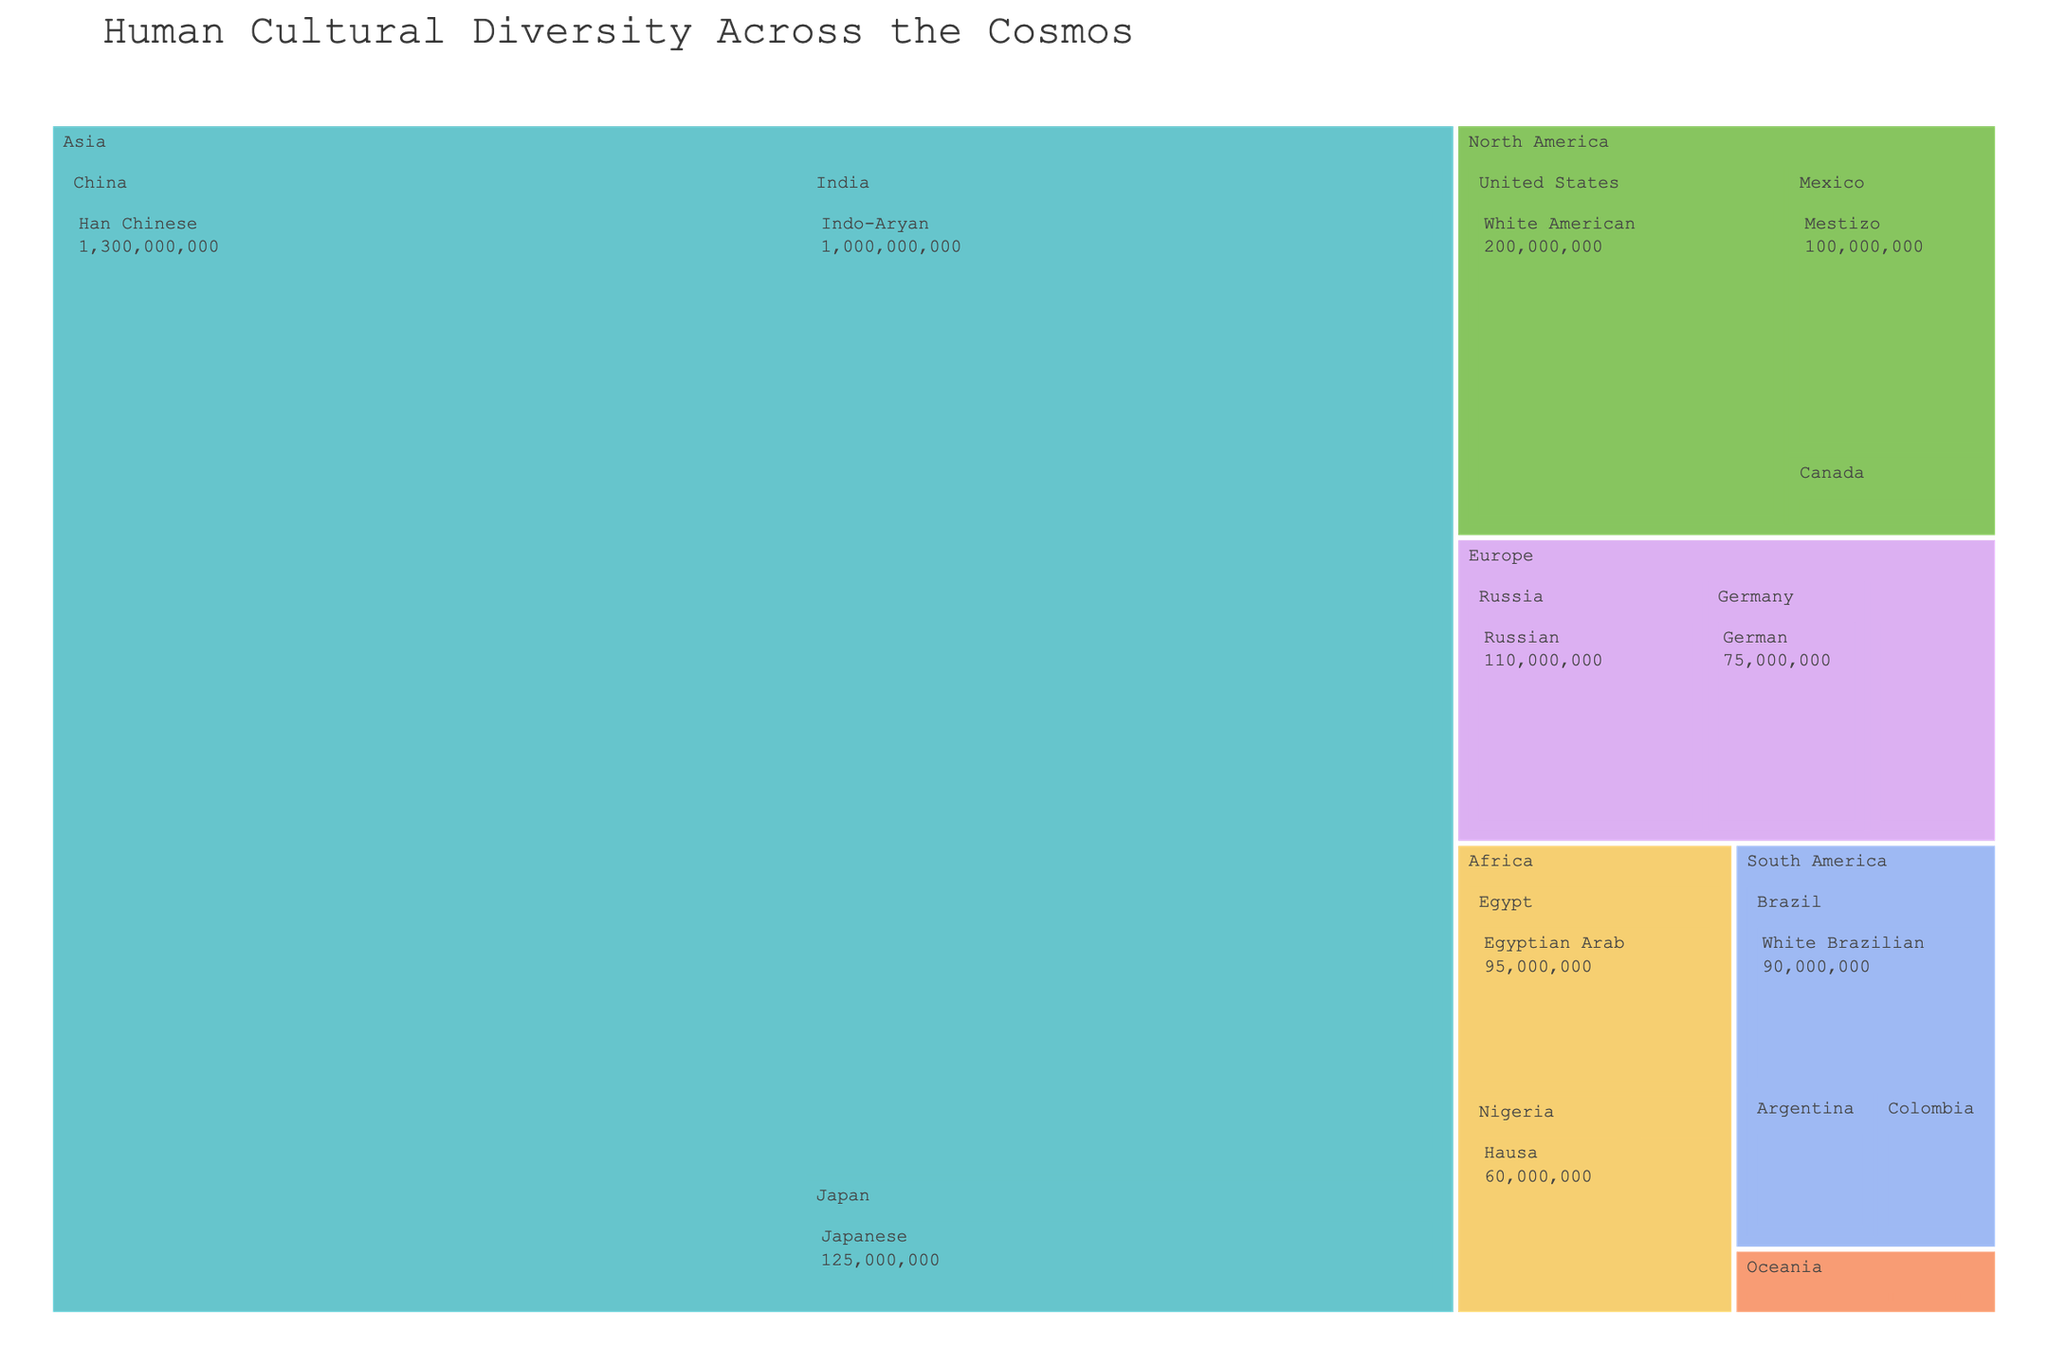What is the title of the figure? The title is located at the top of the figure, typically in a larger font size compared to the rest of the text.
Answer: Human Cultural Diversity Across the Cosmos How many continents are represented in the figure? Count the distinct colored sections labeled with continent names.
Answer: Six Which ethnic group has the highest population? Locate and compare the population values displayed for each ethnic group within the figure.
Answer: Han Chinese What is the combined population of the "White American" and "Mestizo" ethnic groups in North America? Sum the populations of "White American" (200,000,000) and "Mestizo" (100,000,000).
Answer: 300,000,000 Which continent has the lowest population in the figure, based on the ethnic groups listed? Identify and compare the total populations for each continent by summing the populations of their respective ethnic groups.
Answer: Oceania How many ethnic groups are represented in Europe? Count the distinct ethnic groups listed under the continent "Europe".
Answer: Three Which ethnic group in Africa has the smallest population, and what is that population? Locate and compare the population values of each ethnic group within the "Africa" section.
Answer: Oromo with 35,000,000 Between "German" from Germany and "English" from the United Kingdom, which ethnic group has a larger population? Compare the population values of the "German" and "English" ethnic groups.
Answer: German What is the average population of ethnic groups in South America? Sum the populations of the ethnic groups in South America and divide by the number of groups (3). (90,000,000 + 30,000,000 + 35,000,000) / 3
Answer: 51,666,667 How does the population of "Japanese" compare to that of "White Argentine"? Compare the populations of the "Japanese" (125,000,000) and "White Argentine" (35,000,000) ethnic groups.
Answer: Greater 